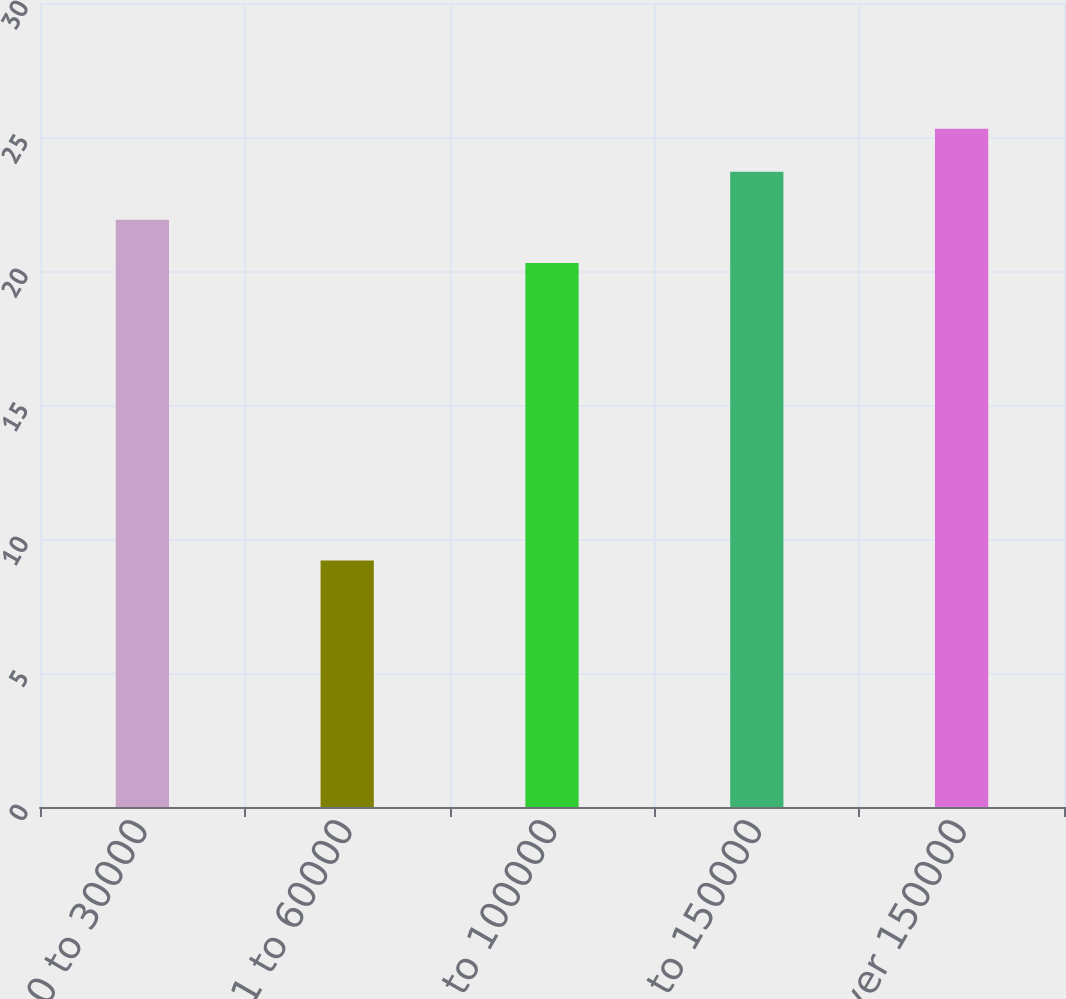Convert chart. <chart><loc_0><loc_0><loc_500><loc_500><bar_chart><fcel>0 to 30000<fcel>30001 to 60000<fcel>60001 to 100000<fcel>100001 to 150000<fcel>Over 150000<nl><fcel>21.91<fcel>9.2<fcel>20.3<fcel>23.7<fcel>25.31<nl></chart> 